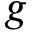<formula> <loc_0><loc_0><loc_500><loc_500>g</formula> 